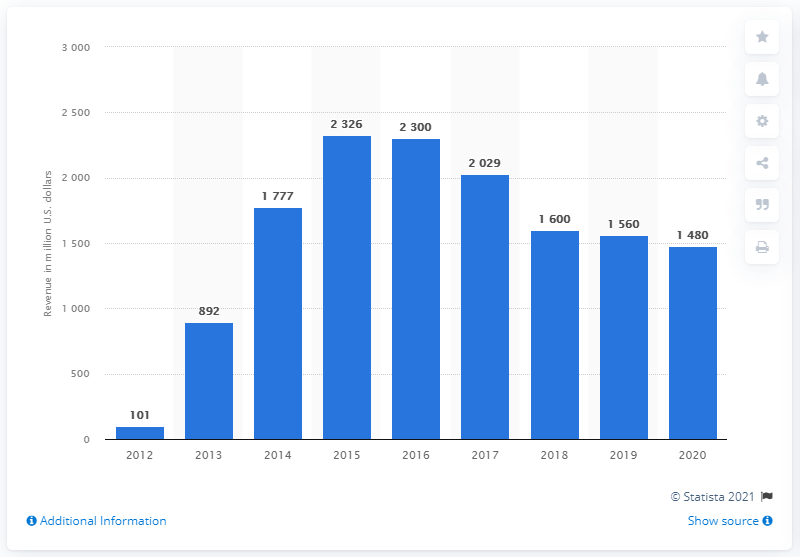List a handful of essential elements in this visual. In 2020, Supercell generated approximately $1,480 million in revenue in the United States. 